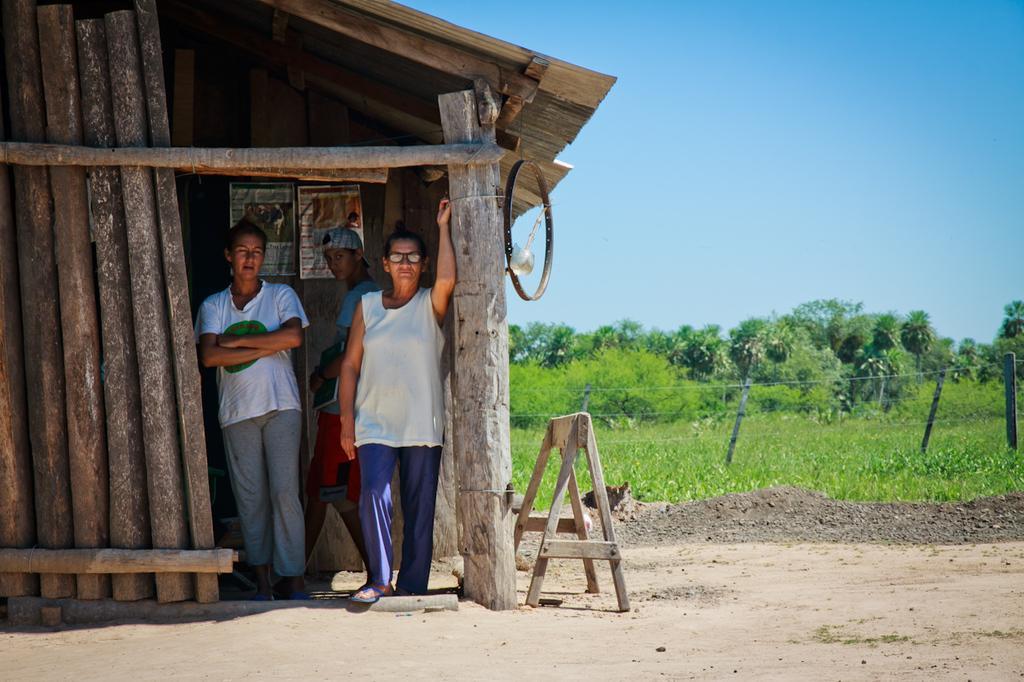Can you describe this image briefly? In this picture there are three people and we can see shed, poles, wheel and wooden object. We can see plants and fence. In the background of the image we can see trees and sky. 